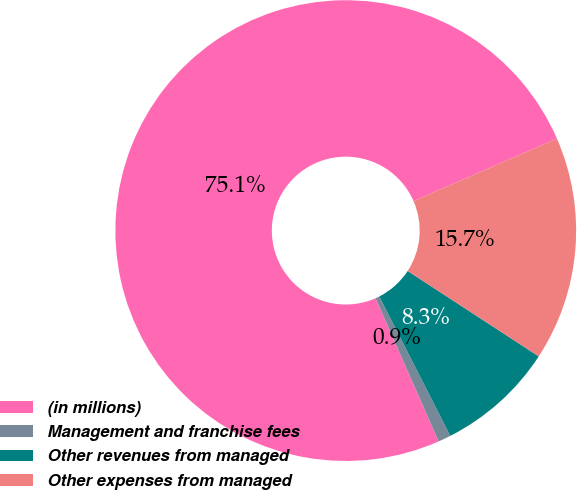Convert chart to OTSL. <chart><loc_0><loc_0><loc_500><loc_500><pie_chart><fcel>(in millions)<fcel>Management and franchise fees<fcel>Other revenues from managed<fcel>Other expenses from managed<nl><fcel>75.07%<fcel>0.89%<fcel>8.31%<fcel>15.73%<nl></chart> 